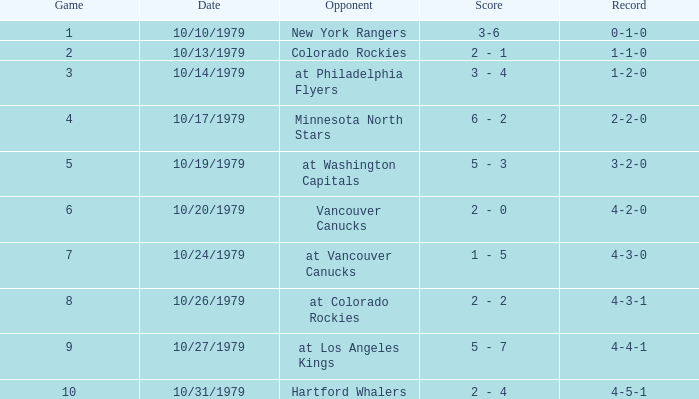What is the score for the adversary vancouver canucks? 2 - 0. 